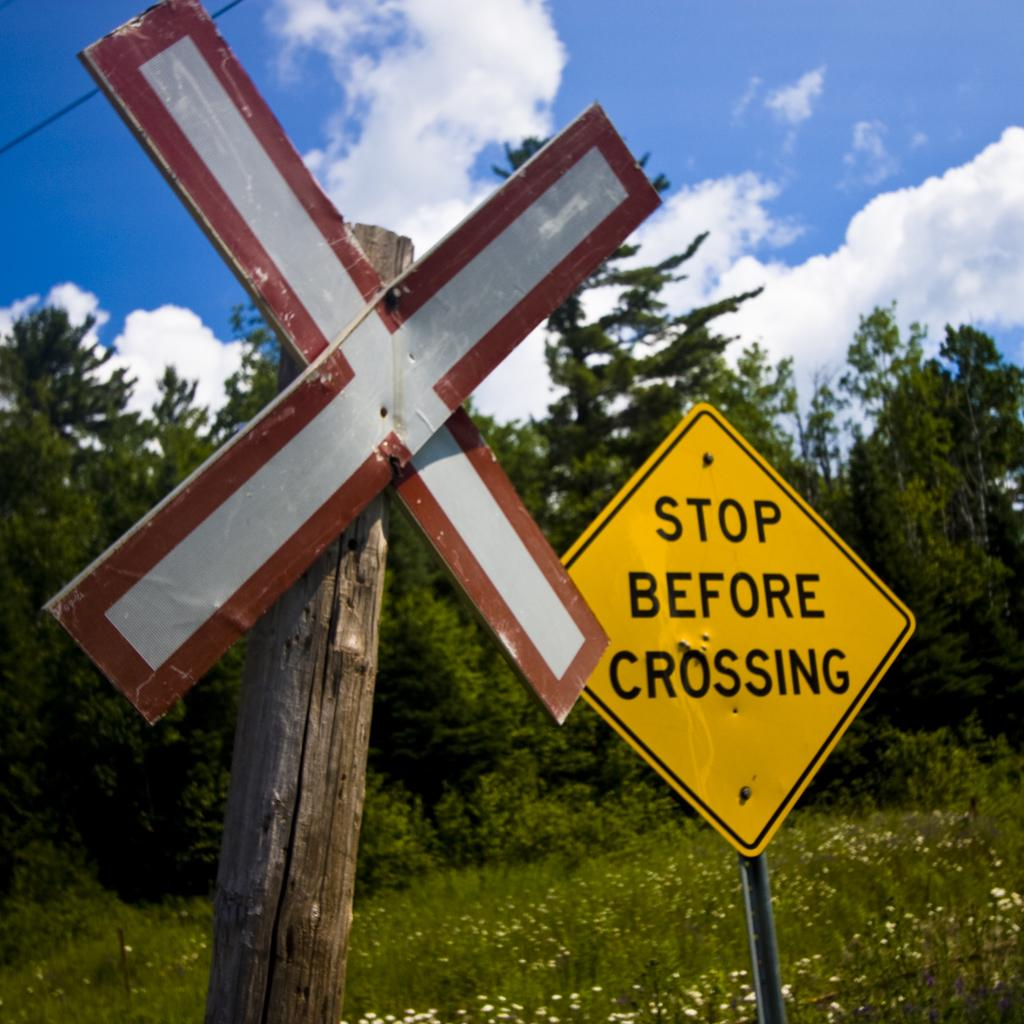<image>
Create a compact narrative representing the image presented. A railroad crossing sign hangs next to a sign that says stop before crossing. 